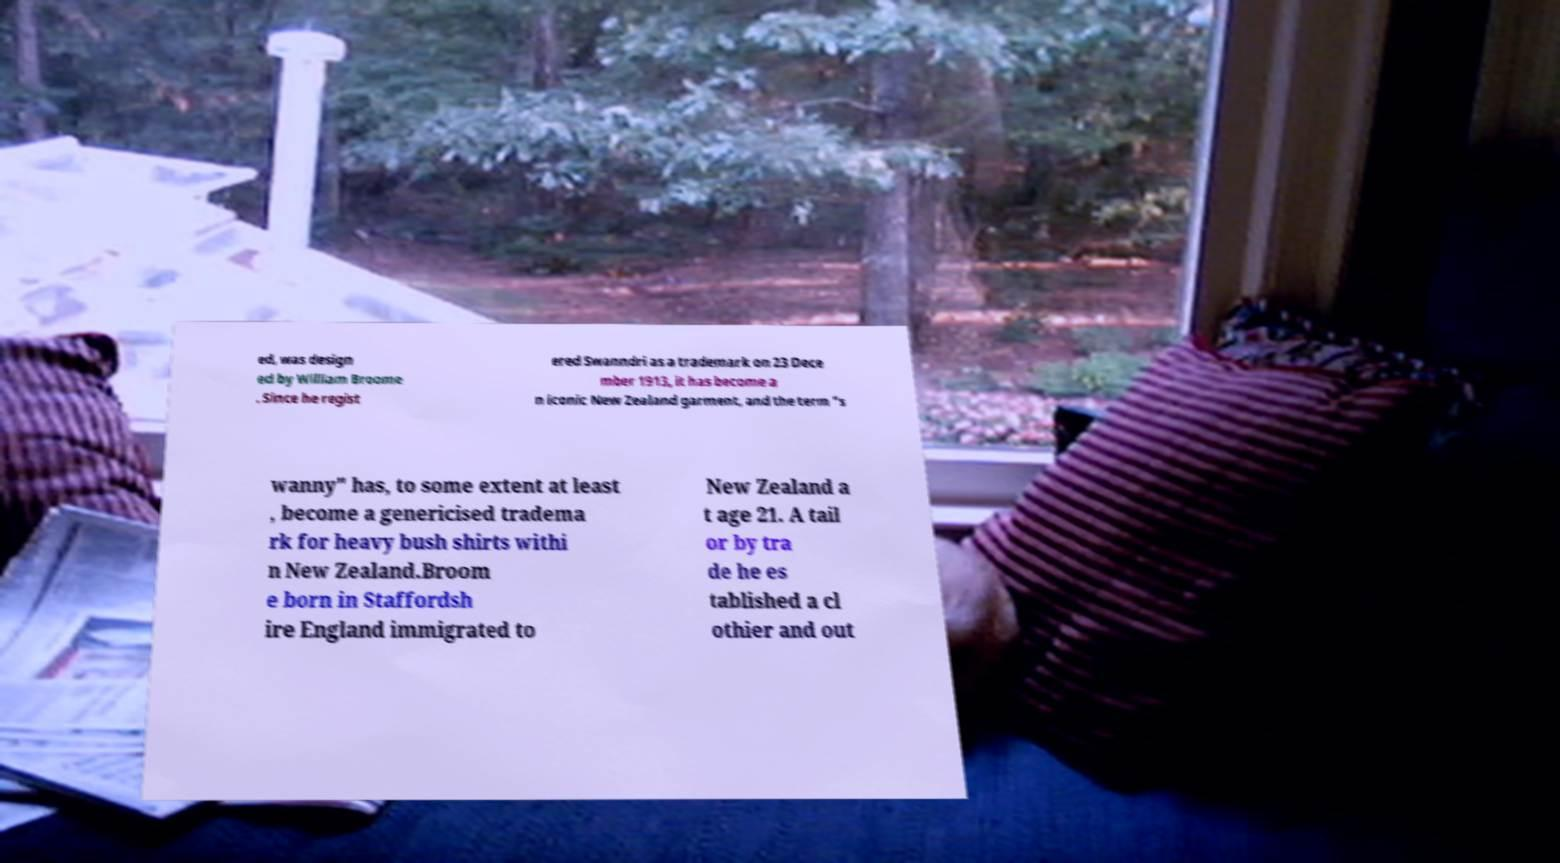For documentation purposes, I need the text within this image transcribed. Could you provide that? ed, was design ed by William Broome . Since he regist ered Swanndri as a trademark on 23 Dece mber 1913, it has become a n iconic New Zealand garment, and the term "s wanny" has, to some extent at least , become a genericised tradema rk for heavy bush shirts withi n New Zealand.Broom e born in Staffordsh ire England immigrated to New Zealand a t age 21. A tail or by tra de he es tablished a cl othier and out 